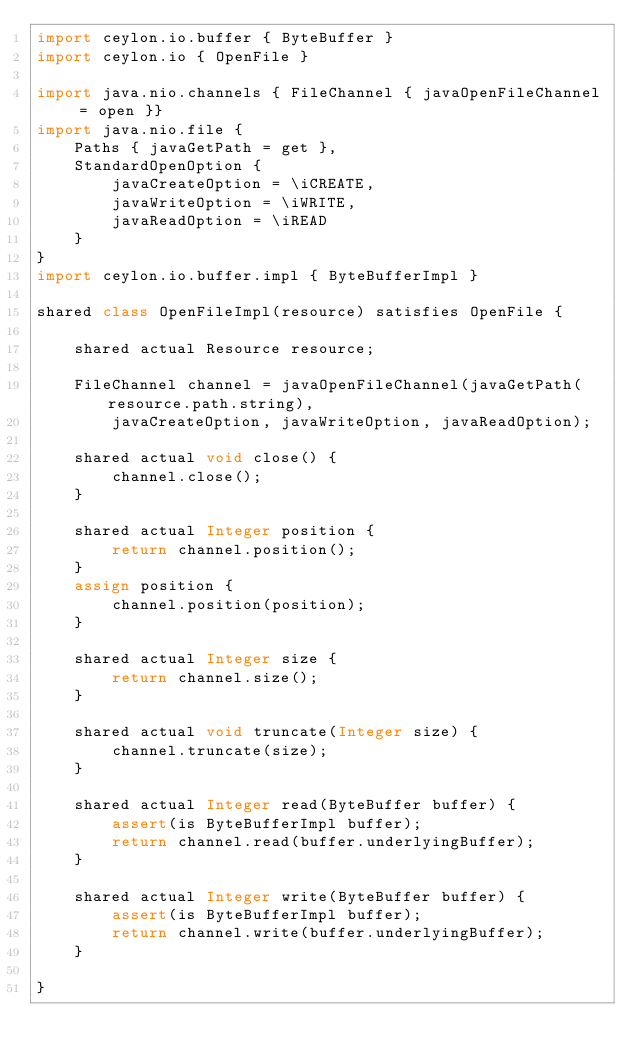Convert code to text. <code><loc_0><loc_0><loc_500><loc_500><_Ceylon_>import ceylon.io.buffer { ByteBuffer }
import ceylon.io { OpenFile }

import java.nio.channels { FileChannel { javaOpenFileChannel = open }}
import java.nio.file { 
	Paths { javaGetPath = get },
	StandardOpenOption { 
		javaCreateOption = \iCREATE,
		javaWriteOption = \iWRITE,
		javaReadOption = \iREAD
	}
}
import ceylon.io.buffer.impl { ByteBufferImpl }

shared class OpenFileImpl(resource) satisfies OpenFile {
    
    shared actual Resource resource;

	FileChannel channel = javaOpenFileChannel(javaGetPath(resource.path.string), 
		javaCreateOption, javaWriteOption, javaReadOption);
    
    shared actual void close() {
        channel.close();
    }

    shared actual Integer position {
        return channel.position();
    }
    assign position {
        channel.position(position);
    }

    shared actual Integer size {
        return channel.size();
    }

    shared actual void truncate(Integer size) {
        channel.truncate(size);
    }

    shared actual Integer read(ByteBuffer buffer) {
        assert(is ByteBufferImpl buffer);
        return channel.read(buffer.underlyingBuffer);
    }

    shared actual Integer write(ByteBuffer buffer) {
        assert(is ByteBufferImpl buffer);
        return channel.write(buffer.underlyingBuffer);
    }

}</code> 